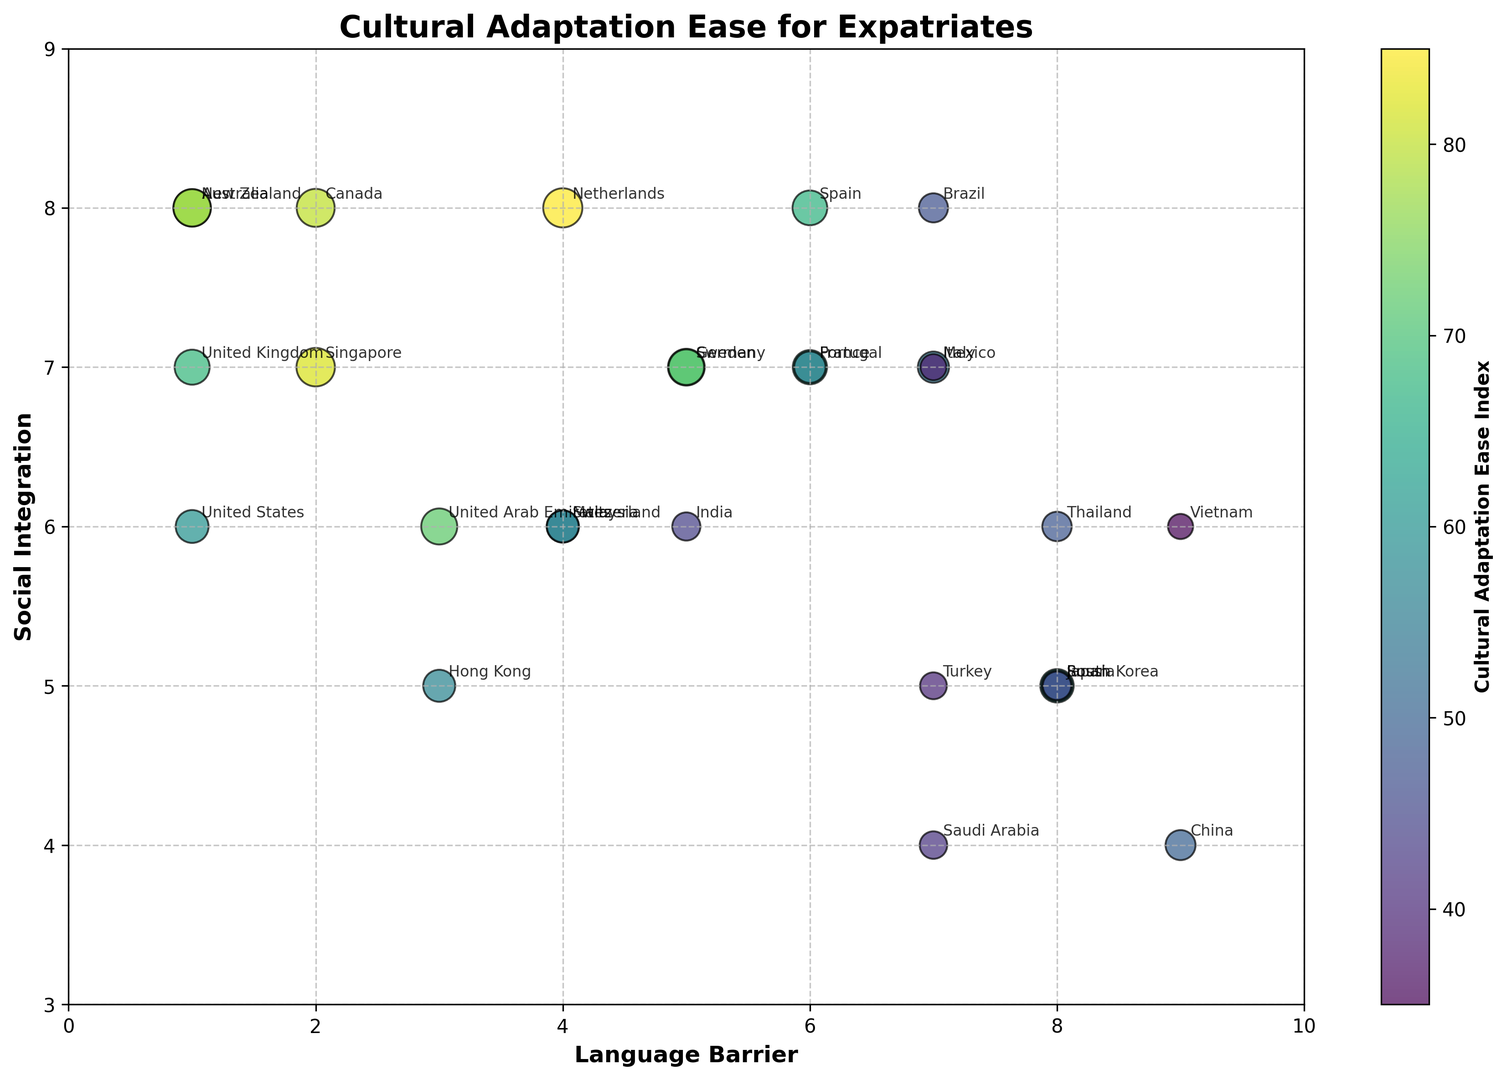Which country has the highest Cultural Adaptation Ease Index for expatriates? Look for the country with the largest bubble and the highest index value in the color bar. The Netherlands has the highest index value of 85.
Answer: Netherlands Which country has a higher Social Integration score, Singapore or South Korea? Compare the vertical position (Y-axis) of the bubbles representing Singapore and South Korea. Singapore has a score of 7, while South Korea has a score of 5.
Answer: Singapore Among Canada, Australia, and the United States, which country has the lowest Language Barrier score? Compare the horizontal position (X-axis) of the bubbles representing these countries. Canada's and Australia's score is 2, whereas the United States' score is 1.
Answer: United States Is there a country with both high Language Barrier and high Social Integration scores? Identify bubbles on the plot where both the X-axis (Language Barrier) is high (closer to 10) and Y-axis (Social Integration) is high (closer to 10). Spain with Language Barrier 6 and Social Integration 8 fits this description.
Answer: Spain What is the Cultural Adaptation Ease Index for Italy, and how does it compare to Sweden? Locate the bubbles for Italy and Sweden and compare the color intensity or refer to their labels. Italy's Index is 54, while Sweden's is 70.
Answer: Italy: 54, Sweden: 70 What range of Language Barrier scores has the highest concentration of countries with a Cultural Adaptation Ease Index greater than 70? Look for the bubbles with an index value higher than 70 and determine their position on the X-axis for Language Barrier scores. Most such countries are in the 1-5 range (like Netherlands, Canada, and Singapore).
Answer: 1-5 Which country has a Cultural Adaptation Ease Index closest to the median value of all the countries in the chart? Calculate the median of the Cultural Adaptation Ease Index values and then find the closest value among the countries. The median value is approximately 58, so Switzerland has an index closest to it.
Answer: Switzerland 